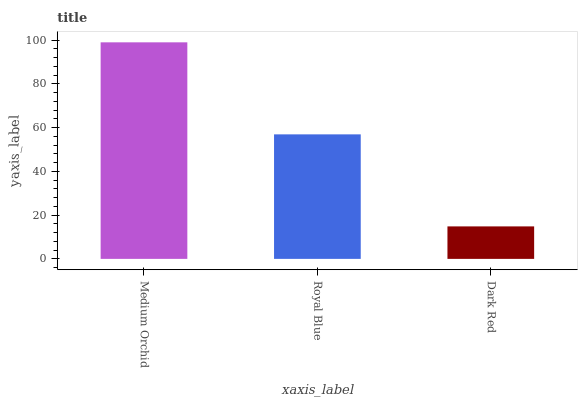Is Dark Red the minimum?
Answer yes or no. Yes. Is Medium Orchid the maximum?
Answer yes or no. Yes. Is Royal Blue the minimum?
Answer yes or no. No. Is Royal Blue the maximum?
Answer yes or no. No. Is Medium Orchid greater than Royal Blue?
Answer yes or no. Yes. Is Royal Blue less than Medium Orchid?
Answer yes or no. Yes. Is Royal Blue greater than Medium Orchid?
Answer yes or no. No. Is Medium Orchid less than Royal Blue?
Answer yes or no. No. Is Royal Blue the high median?
Answer yes or no. Yes. Is Royal Blue the low median?
Answer yes or no. Yes. Is Dark Red the high median?
Answer yes or no. No. Is Dark Red the low median?
Answer yes or no. No. 